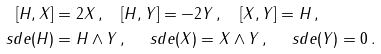<formula> <loc_0><loc_0><loc_500><loc_500>[ H , X ] & = 2 X \, , \quad [ H , Y ] = - 2 Y \, , \quad [ X , Y ] = H \, , \\ \ s d e ( H ) & = H \wedge Y \, , \quad \ s d e ( X ) = X \wedge Y \, , \quad \ s d e ( Y ) = 0 \, .</formula> 